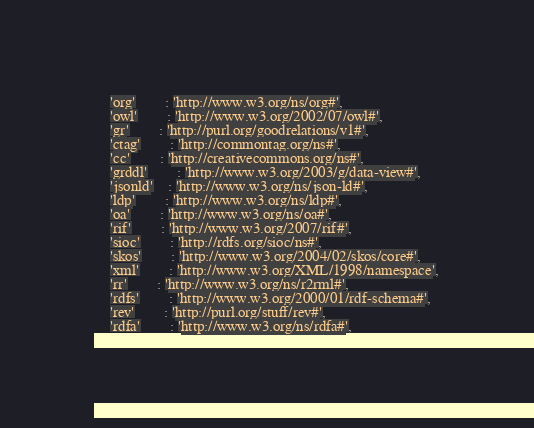Convert code to text. <code><loc_0><loc_0><loc_500><loc_500><_Python_>    'org'		: 'http://www.w3.org/ns/org#',
	'owl'		: 'http://www.w3.org/2002/07/owl#',
	'gr'		: 'http://purl.org/goodrelations/v1#',
	'ctag'		: 'http://commontag.org/ns#',
	'cc'		: 'http://creativecommons.org/ns#',
	'grddl'		: 'http://www.w3.org/2003/g/data-view#',
	'jsonld'    : 'http://www.w3.org/ns/json-ld#',
	'ldp'		: 'http://www.w3.org/ns/ldp#',
	'oa'		: 'http://www.w3.org/ns/oa#',
	'rif'		: 'http://www.w3.org/2007/rif#',
	'sioc'		: 'http://rdfs.org/sioc/ns#',
	'skos'		: 'http://www.w3.org/2004/02/skos/core#',
	'xml'		: 'http://www.w3.org/XML/1998/namespace',
	'rr'		: 'http://www.w3.org/ns/r2rml#',
	'rdfs'		: 'http://www.w3.org/2000/01/rdf-schema#',
	'rev'		: 'http://purl.org/stuff/rev#',
	'rdfa'		: 'http://www.w3.org/ns/rdfa#',</code> 